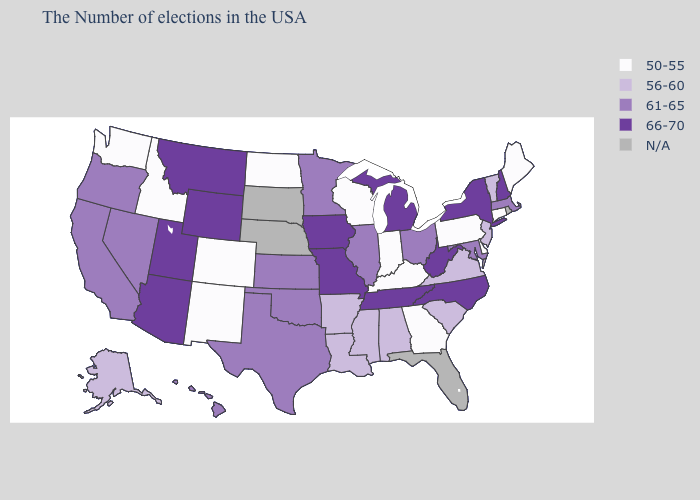What is the highest value in the Northeast ?
Concise answer only. 66-70. Does the map have missing data?
Answer briefly. Yes. Name the states that have a value in the range 56-60?
Keep it brief. Vermont, New Jersey, Virginia, South Carolina, Alabama, Mississippi, Louisiana, Arkansas, Alaska. What is the value of Nevada?
Write a very short answer. 61-65. What is the lowest value in the Northeast?
Give a very brief answer. 50-55. What is the value of Ohio?
Quick response, please. 61-65. Name the states that have a value in the range N/A?
Be succinct. Rhode Island, Florida, Nebraska, South Dakota. Name the states that have a value in the range 56-60?
Concise answer only. Vermont, New Jersey, Virginia, South Carolina, Alabama, Mississippi, Louisiana, Arkansas, Alaska. What is the highest value in the MidWest ?
Short answer required. 66-70. Name the states that have a value in the range 56-60?
Write a very short answer. Vermont, New Jersey, Virginia, South Carolina, Alabama, Mississippi, Louisiana, Arkansas, Alaska. Does Connecticut have the lowest value in the USA?
Give a very brief answer. Yes. Does Wisconsin have the lowest value in the USA?
Answer briefly. Yes. What is the lowest value in the USA?
Concise answer only. 50-55. 